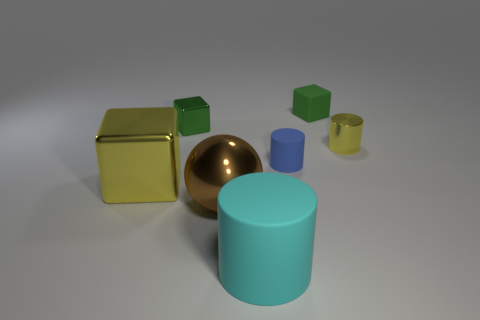Which objects in the image are casting noticeable shadows? The predominant light source in the image seems to be coming from the upper left, casting noticeable shadows to the right of most objects. The yellow cube, the sphere, and the teal cylinder have the most prominent shadows due to their size and positioning relative to the light source. 